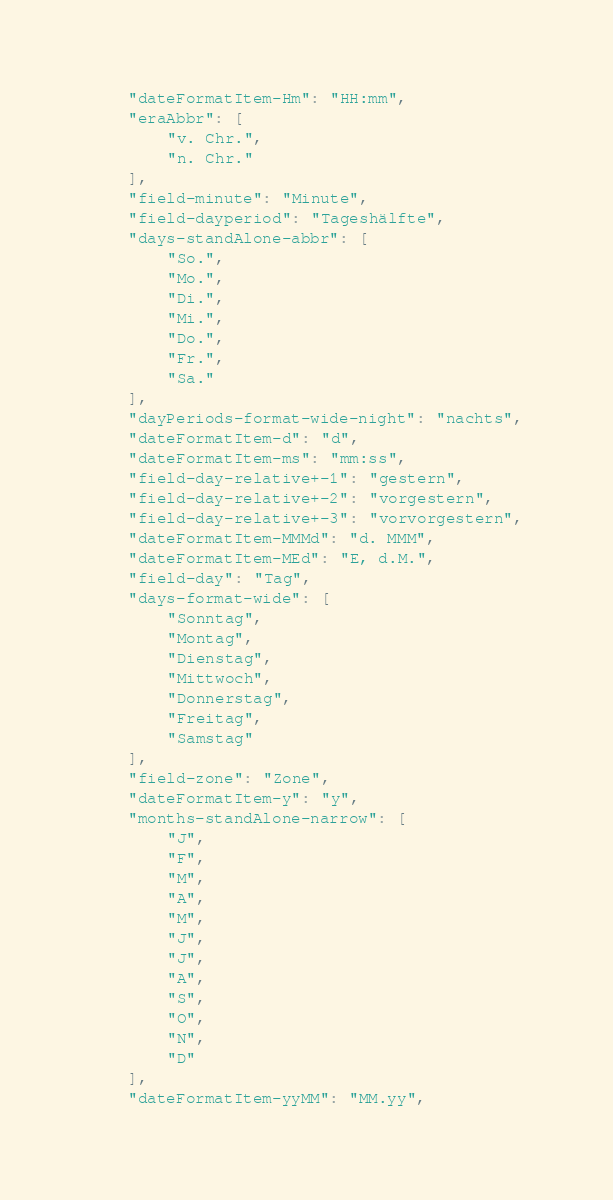<code> <loc_0><loc_0><loc_500><loc_500><_JavaScript_>	"dateFormatItem-Hm": "HH:mm",
	"eraAbbr": [
		"v. Chr.",
		"n. Chr."
	],
	"field-minute": "Minute",
	"field-dayperiod": "Tageshälfte",
	"days-standAlone-abbr": [
		"So.",
		"Mo.",
		"Di.",
		"Mi.",
		"Do.",
		"Fr.",
		"Sa."
	],
	"dayPeriods-format-wide-night": "nachts",
	"dateFormatItem-d": "d",
	"dateFormatItem-ms": "mm:ss",
	"field-day-relative+-1": "gestern",
	"field-day-relative+-2": "vorgestern",
	"field-day-relative+-3": "vorvorgestern",
	"dateFormatItem-MMMd": "d. MMM",
	"dateFormatItem-MEd": "E, d.M.",
	"field-day": "Tag",
	"days-format-wide": [
		"Sonntag",
		"Montag",
		"Dienstag",
		"Mittwoch",
		"Donnerstag",
		"Freitag",
		"Samstag"
	],
	"field-zone": "Zone",
	"dateFormatItem-y": "y",
	"months-standAlone-narrow": [
		"J",
		"F",
		"M",
		"A",
		"M",
		"J",
		"J",
		"A",
		"S",
		"O",
		"N",
		"D"
	],
	"dateFormatItem-yyMM": "MM.yy",</code> 